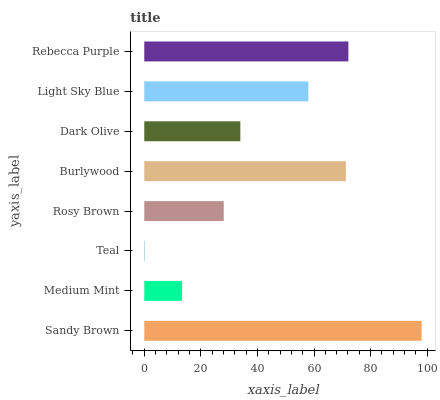Is Teal the minimum?
Answer yes or no. Yes. Is Sandy Brown the maximum?
Answer yes or no. Yes. Is Medium Mint the minimum?
Answer yes or no. No. Is Medium Mint the maximum?
Answer yes or no. No. Is Sandy Brown greater than Medium Mint?
Answer yes or no. Yes. Is Medium Mint less than Sandy Brown?
Answer yes or no. Yes. Is Medium Mint greater than Sandy Brown?
Answer yes or no. No. Is Sandy Brown less than Medium Mint?
Answer yes or no. No. Is Light Sky Blue the high median?
Answer yes or no. Yes. Is Dark Olive the low median?
Answer yes or no. Yes. Is Sandy Brown the high median?
Answer yes or no. No. Is Burlywood the low median?
Answer yes or no. No. 